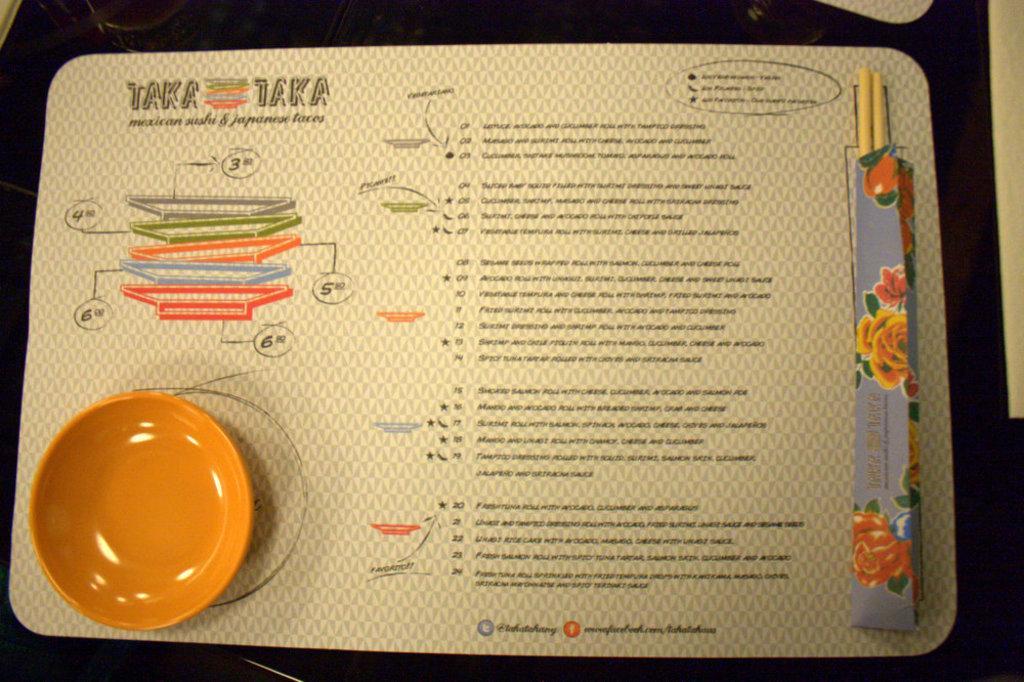Can you describe this image briefly? In this picture I can see a plate on the left side, in the middle there is the text on the board. 